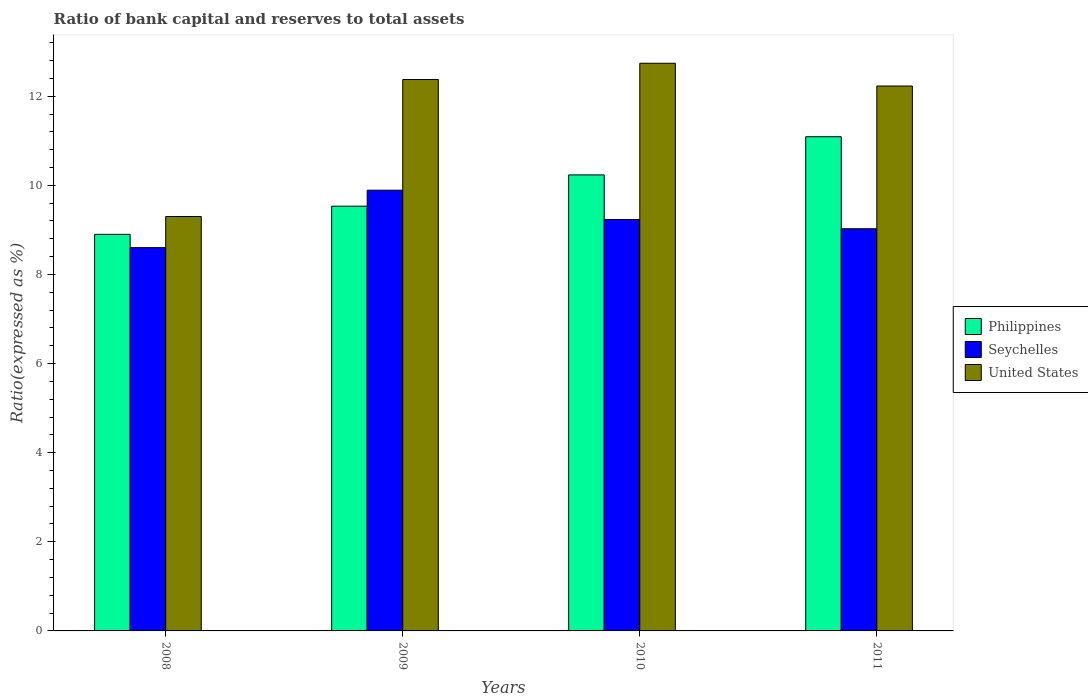How many bars are there on the 1st tick from the right?
Offer a terse response. 3. What is the ratio of bank capital and reserves to total assets in Seychelles in 2008?
Offer a very short reply. 8.6. Across all years, what is the maximum ratio of bank capital and reserves to total assets in Seychelles?
Give a very brief answer. 9.89. Across all years, what is the minimum ratio of bank capital and reserves to total assets in Seychelles?
Provide a succinct answer. 8.6. In which year was the ratio of bank capital and reserves to total assets in United States minimum?
Keep it short and to the point. 2008. What is the total ratio of bank capital and reserves to total assets in Seychelles in the graph?
Your answer should be very brief. 36.75. What is the difference between the ratio of bank capital and reserves to total assets in United States in 2008 and that in 2010?
Your answer should be very brief. -3.44. What is the difference between the ratio of bank capital and reserves to total assets in United States in 2008 and the ratio of bank capital and reserves to total assets in Philippines in 2009?
Offer a very short reply. -0.23. What is the average ratio of bank capital and reserves to total assets in Seychelles per year?
Provide a succinct answer. 9.19. In the year 2008, what is the difference between the ratio of bank capital and reserves to total assets in United States and ratio of bank capital and reserves to total assets in Philippines?
Make the answer very short. 0.4. What is the ratio of the ratio of bank capital and reserves to total assets in United States in 2010 to that in 2011?
Offer a very short reply. 1.04. What is the difference between the highest and the second highest ratio of bank capital and reserves to total assets in Philippines?
Keep it short and to the point. 0.86. What is the difference between the highest and the lowest ratio of bank capital and reserves to total assets in Seychelles?
Make the answer very short. 1.29. In how many years, is the ratio of bank capital and reserves to total assets in Seychelles greater than the average ratio of bank capital and reserves to total assets in Seychelles taken over all years?
Keep it short and to the point. 2. What does the 2nd bar from the left in 2011 represents?
Provide a short and direct response. Seychelles. What does the 2nd bar from the right in 2011 represents?
Keep it short and to the point. Seychelles. Are all the bars in the graph horizontal?
Make the answer very short. No. What is the difference between two consecutive major ticks on the Y-axis?
Your response must be concise. 2. Are the values on the major ticks of Y-axis written in scientific E-notation?
Give a very brief answer. No. Does the graph contain any zero values?
Keep it short and to the point. No. How many legend labels are there?
Make the answer very short. 3. How are the legend labels stacked?
Your answer should be compact. Vertical. What is the title of the graph?
Keep it short and to the point. Ratio of bank capital and reserves to total assets. Does "French Polynesia" appear as one of the legend labels in the graph?
Offer a very short reply. No. What is the label or title of the Y-axis?
Your answer should be compact. Ratio(expressed as %). What is the Ratio(expressed as %) in Philippines in 2008?
Keep it short and to the point. 8.9. What is the Ratio(expressed as %) of Seychelles in 2008?
Ensure brevity in your answer.  8.6. What is the Ratio(expressed as %) of Philippines in 2009?
Provide a short and direct response. 9.53. What is the Ratio(expressed as %) of Seychelles in 2009?
Your response must be concise. 9.89. What is the Ratio(expressed as %) of United States in 2009?
Provide a short and direct response. 12.37. What is the Ratio(expressed as %) of Philippines in 2010?
Provide a succinct answer. 10.23. What is the Ratio(expressed as %) of Seychelles in 2010?
Your answer should be very brief. 9.23. What is the Ratio(expressed as %) in United States in 2010?
Give a very brief answer. 12.74. What is the Ratio(expressed as %) in Philippines in 2011?
Offer a very short reply. 11.09. What is the Ratio(expressed as %) in Seychelles in 2011?
Provide a succinct answer. 9.03. What is the Ratio(expressed as %) of United States in 2011?
Make the answer very short. 12.23. Across all years, what is the maximum Ratio(expressed as %) in Philippines?
Your answer should be compact. 11.09. Across all years, what is the maximum Ratio(expressed as %) of Seychelles?
Offer a very short reply. 9.89. Across all years, what is the maximum Ratio(expressed as %) in United States?
Offer a very short reply. 12.74. Across all years, what is the minimum Ratio(expressed as %) in Seychelles?
Your answer should be very brief. 8.6. What is the total Ratio(expressed as %) in Philippines in the graph?
Your response must be concise. 39.76. What is the total Ratio(expressed as %) of Seychelles in the graph?
Ensure brevity in your answer.  36.75. What is the total Ratio(expressed as %) of United States in the graph?
Give a very brief answer. 46.64. What is the difference between the Ratio(expressed as %) in Philippines in 2008 and that in 2009?
Make the answer very short. -0.63. What is the difference between the Ratio(expressed as %) of Seychelles in 2008 and that in 2009?
Offer a very short reply. -1.29. What is the difference between the Ratio(expressed as %) of United States in 2008 and that in 2009?
Make the answer very short. -3.07. What is the difference between the Ratio(expressed as %) in Philippines in 2008 and that in 2010?
Keep it short and to the point. -1.33. What is the difference between the Ratio(expressed as %) in Seychelles in 2008 and that in 2010?
Give a very brief answer. -0.63. What is the difference between the Ratio(expressed as %) in United States in 2008 and that in 2010?
Offer a very short reply. -3.44. What is the difference between the Ratio(expressed as %) of Philippines in 2008 and that in 2011?
Keep it short and to the point. -2.19. What is the difference between the Ratio(expressed as %) of Seychelles in 2008 and that in 2011?
Offer a terse response. -0.42. What is the difference between the Ratio(expressed as %) in United States in 2008 and that in 2011?
Provide a succinct answer. -2.93. What is the difference between the Ratio(expressed as %) of Philippines in 2009 and that in 2010?
Make the answer very short. -0.7. What is the difference between the Ratio(expressed as %) of Seychelles in 2009 and that in 2010?
Provide a short and direct response. 0.66. What is the difference between the Ratio(expressed as %) in United States in 2009 and that in 2010?
Give a very brief answer. -0.36. What is the difference between the Ratio(expressed as %) of Philippines in 2009 and that in 2011?
Make the answer very short. -1.56. What is the difference between the Ratio(expressed as %) in Seychelles in 2009 and that in 2011?
Your response must be concise. 0.86. What is the difference between the Ratio(expressed as %) in United States in 2009 and that in 2011?
Provide a short and direct response. 0.15. What is the difference between the Ratio(expressed as %) of Philippines in 2010 and that in 2011?
Provide a succinct answer. -0.86. What is the difference between the Ratio(expressed as %) in Seychelles in 2010 and that in 2011?
Your answer should be compact. 0.21. What is the difference between the Ratio(expressed as %) of United States in 2010 and that in 2011?
Ensure brevity in your answer.  0.51. What is the difference between the Ratio(expressed as %) of Philippines in 2008 and the Ratio(expressed as %) of Seychelles in 2009?
Your answer should be very brief. -0.99. What is the difference between the Ratio(expressed as %) in Philippines in 2008 and the Ratio(expressed as %) in United States in 2009?
Ensure brevity in your answer.  -3.47. What is the difference between the Ratio(expressed as %) in Seychelles in 2008 and the Ratio(expressed as %) in United States in 2009?
Give a very brief answer. -3.77. What is the difference between the Ratio(expressed as %) in Philippines in 2008 and the Ratio(expressed as %) in Seychelles in 2010?
Your answer should be very brief. -0.33. What is the difference between the Ratio(expressed as %) in Philippines in 2008 and the Ratio(expressed as %) in United States in 2010?
Make the answer very short. -3.84. What is the difference between the Ratio(expressed as %) in Seychelles in 2008 and the Ratio(expressed as %) in United States in 2010?
Your response must be concise. -4.14. What is the difference between the Ratio(expressed as %) in Philippines in 2008 and the Ratio(expressed as %) in Seychelles in 2011?
Keep it short and to the point. -0.13. What is the difference between the Ratio(expressed as %) in Philippines in 2008 and the Ratio(expressed as %) in United States in 2011?
Make the answer very short. -3.33. What is the difference between the Ratio(expressed as %) in Seychelles in 2008 and the Ratio(expressed as %) in United States in 2011?
Provide a succinct answer. -3.63. What is the difference between the Ratio(expressed as %) in Philippines in 2009 and the Ratio(expressed as %) in Seychelles in 2010?
Your answer should be compact. 0.3. What is the difference between the Ratio(expressed as %) of Philippines in 2009 and the Ratio(expressed as %) of United States in 2010?
Offer a very short reply. -3.21. What is the difference between the Ratio(expressed as %) of Seychelles in 2009 and the Ratio(expressed as %) of United States in 2010?
Your answer should be compact. -2.85. What is the difference between the Ratio(expressed as %) in Philippines in 2009 and the Ratio(expressed as %) in Seychelles in 2011?
Offer a very short reply. 0.51. What is the difference between the Ratio(expressed as %) of Philippines in 2009 and the Ratio(expressed as %) of United States in 2011?
Offer a terse response. -2.7. What is the difference between the Ratio(expressed as %) in Seychelles in 2009 and the Ratio(expressed as %) in United States in 2011?
Ensure brevity in your answer.  -2.34. What is the difference between the Ratio(expressed as %) of Philippines in 2010 and the Ratio(expressed as %) of Seychelles in 2011?
Provide a short and direct response. 1.21. What is the difference between the Ratio(expressed as %) of Philippines in 2010 and the Ratio(expressed as %) of United States in 2011?
Offer a very short reply. -2. What is the difference between the Ratio(expressed as %) in Seychelles in 2010 and the Ratio(expressed as %) in United States in 2011?
Offer a very short reply. -3. What is the average Ratio(expressed as %) in Philippines per year?
Ensure brevity in your answer.  9.94. What is the average Ratio(expressed as %) in Seychelles per year?
Ensure brevity in your answer.  9.19. What is the average Ratio(expressed as %) in United States per year?
Your answer should be compact. 11.66. In the year 2008, what is the difference between the Ratio(expressed as %) of Philippines and Ratio(expressed as %) of Seychelles?
Ensure brevity in your answer.  0.3. In the year 2008, what is the difference between the Ratio(expressed as %) of Seychelles and Ratio(expressed as %) of United States?
Keep it short and to the point. -0.7. In the year 2009, what is the difference between the Ratio(expressed as %) in Philippines and Ratio(expressed as %) in Seychelles?
Provide a short and direct response. -0.36. In the year 2009, what is the difference between the Ratio(expressed as %) of Philippines and Ratio(expressed as %) of United States?
Provide a succinct answer. -2.84. In the year 2009, what is the difference between the Ratio(expressed as %) in Seychelles and Ratio(expressed as %) in United States?
Provide a short and direct response. -2.48. In the year 2010, what is the difference between the Ratio(expressed as %) in Philippines and Ratio(expressed as %) in United States?
Your answer should be compact. -2.51. In the year 2010, what is the difference between the Ratio(expressed as %) in Seychelles and Ratio(expressed as %) in United States?
Make the answer very short. -3.51. In the year 2011, what is the difference between the Ratio(expressed as %) in Philippines and Ratio(expressed as %) in Seychelles?
Your answer should be very brief. 2.06. In the year 2011, what is the difference between the Ratio(expressed as %) in Philippines and Ratio(expressed as %) in United States?
Provide a succinct answer. -1.14. In the year 2011, what is the difference between the Ratio(expressed as %) in Seychelles and Ratio(expressed as %) in United States?
Give a very brief answer. -3.2. What is the ratio of the Ratio(expressed as %) in Philippines in 2008 to that in 2009?
Offer a very short reply. 0.93. What is the ratio of the Ratio(expressed as %) in Seychelles in 2008 to that in 2009?
Your response must be concise. 0.87. What is the ratio of the Ratio(expressed as %) in United States in 2008 to that in 2009?
Provide a short and direct response. 0.75. What is the ratio of the Ratio(expressed as %) in Philippines in 2008 to that in 2010?
Offer a very short reply. 0.87. What is the ratio of the Ratio(expressed as %) in Seychelles in 2008 to that in 2010?
Offer a very short reply. 0.93. What is the ratio of the Ratio(expressed as %) of United States in 2008 to that in 2010?
Give a very brief answer. 0.73. What is the ratio of the Ratio(expressed as %) of Philippines in 2008 to that in 2011?
Give a very brief answer. 0.8. What is the ratio of the Ratio(expressed as %) of Seychelles in 2008 to that in 2011?
Your answer should be compact. 0.95. What is the ratio of the Ratio(expressed as %) of United States in 2008 to that in 2011?
Offer a terse response. 0.76. What is the ratio of the Ratio(expressed as %) of Philippines in 2009 to that in 2010?
Your answer should be very brief. 0.93. What is the ratio of the Ratio(expressed as %) of Seychelles in 2009 to that in 2010?
Keep it short and to the point. 1.07. What is the ratio of the Ratio(expressed as %) of United States in 2009 to that in 2010?
Give a very brief answer. 0.97. What is the ratio of the Ratio(expressed as %) of Philippines in 2009 to that in 2011?
Keep it short and to the point. 0.86. What is the ratio of the Ratio(expressed as %) of Seychelles in 2009 to that in 2011?
Provide a succinct answer. 1.1. What is the ratio of the Ratio(expressed as %) of United States in 2009 to that in 2011?
Give a very brief answer. 1.01. What is the ratio of the Ratio(expressed as %) of Philippines in 2010 to that in 2011?
Ensure brevity in your answer.  0.92. What is the ratio of the Ratio(expressed as %) in Seychelles in 2010 to that in 2011?
Give a very brief answer. 1.02. What is the ratio of the Ratio(expressed as %) of United States in 2010 to that in 2011?
Provide a succinct answer. 1.04. What is the difference between the highest and the second highest Ratio(expressed as %) of Philippines?
Provide a succinct answer. 0.86. What is the difference between the highest and the second highest Ratio(expressed as %) in Seychelles?
Offer a terse response. 0.66. What is the difference between the highest and the second highest Ratio(expressed as %) of United States?
Your response must be concise. 0.36. What is the difference between the highest and the lowest Ratio(expressed as %) of Philippines?
Keep it short and to the point. 2.19. What is the difference between the highest and the lowest Ratio(expressed as %) of Seychelles?
Offer a terse response. 1.29. What is the difference between the highest and the lowest Ratio(expressed as %) in United States?
Give a very brief answer. 3.44. 